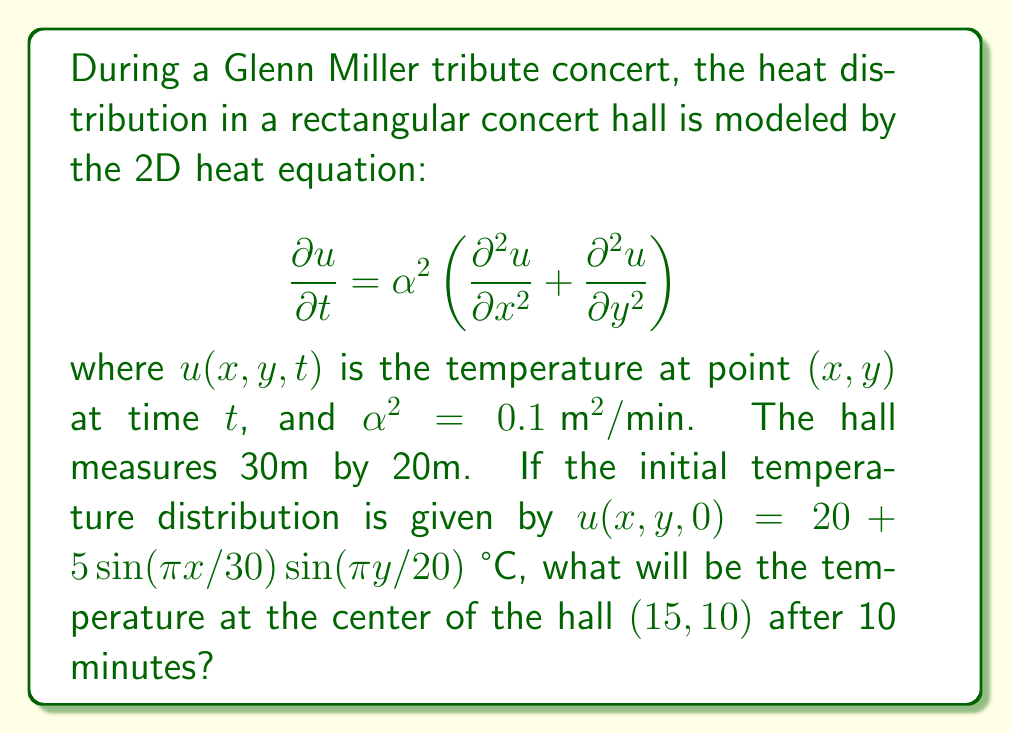Can you answer this question? Let's approach this step-by-step:

1) The general solution to the 2D heat equation with initial condition $u(x,y,0) = f(x,y)$ is:

   $$u(x,y,t) = \sum_{m=1}^{\infty}\sum_{n=1}^{\infty} A_{mn}e^{-\alpha^2(\frac{m^2\pi^2}{L_x^2}+\frac{n^2\pi^2}{L_y^2})t}\sin(\frac{m\pi x}{L_x})\sin(\frac{n\pi y}{L_y})$$

   where $L_x$ and $L_y$ are the dimensions of the rectangle.

2) In our case, $L_x = 30$, $L_y = 20$, and the initial condition matches this form with $m=n=1$ and $A_{11} = 5$. The constant term 20 remains unchanged over time.

3) Therefore, our solution is:

   $$u(x,y,t) = 20 + 5e^{-\alpha^2(\frac{\pi^2}{30^2}+\frac{\pi^2}{20^2})t}\sin(\frac{\pi x}{30})\sin(\frac{\pi y}{20})$$

4) We need to evaluate this at $x=15$, $y=10$, $t=10$, and $\alpha^2 = 0.1$:

   $$u(15,10,10) = 20 + 5e^{-0.1(\frac{\pi^2}{30^2}+\frac{\pi^2}{20^2})10}\sin(\frac{\pi 15}{30})\sin(\frac{\pi 10}{20})$$

5) Simplify:
   
   $$= 20 + 5e^{-0.1(\frac{\pi^2}{900}+\frac{\pi^2}{400})10}\sin(\frac{\pi}{2})\sin(\frac{\pi}{2})$$
   
   $$= 20 + 5e^{-0.1\pi^2(\frac{1}{900}+\frac{1}{400})10}(1)(1)$$

6) Calculate:
   
   $$= 20 + 5e^{-0.00873\pi^2}$$
   
   $$\approx 20 + 5(0.9169)$$
   
   $$\approx 24.5845 \text{ °C}$$
Answer: 24.58 °C 